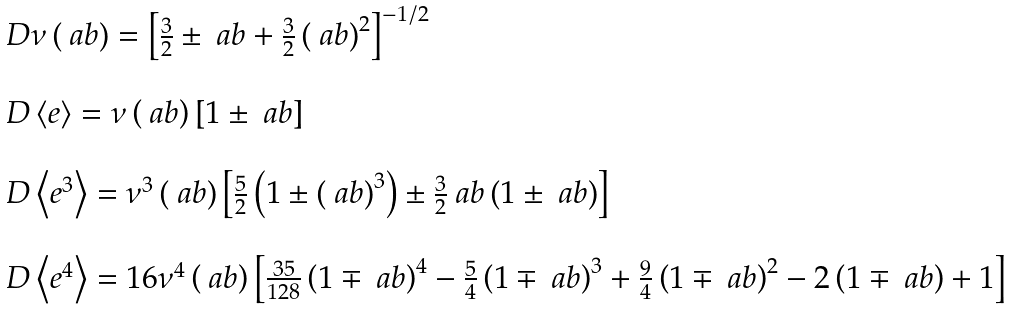<formula> <loc_0><loc_0><loc_500><loc_500>\begin{array} { l } \ D \nu \left ( \ a b \right ) = \left [ \frac { 3 } { 2 } \pm \ a b + \frac { 3 } { 2 } \left ( \ a b \right ) ^ { 2 } \right ] ^ { - 1 / 2 } \\ \\ \ D \left < e \right > = \nu \left ( \ a b \right ) \left [ 1 \pm \ a b \right ] \\ \\ \ D \left < e ^ { 3 } \right > = \nu ^ { 3 } \left ( \ a b \right ) \left [ \frac { 5 } { 2 } \left ( 1 \pm \left ( \ a b \right ) ^ { 3 } \right ) \pm \frac { 3 } { 2 } \ a b \left ( 1 \pm \ a b \right ) \right ] \\ \\ \ D \left < e ^ { 4 } \right > = 1 6 \nu ^ { 4 } \left ( \ a b \right ) \left [ \frac { 3 5 } { 1 2 8 } \left ( 1 \mp \ a b \right ) ^ { 4 } - \frac { 5 } { 4 } \left ( 1 \mp \ a b \right ) ^ { 3 } + \frac { 9 } { 4 } \left ( 1 \mp \ a b \right ) ^ { 2 } - 2 \left ( 1 \mp \ a b \right ) + 1 \right ] \end{array}</formula> 